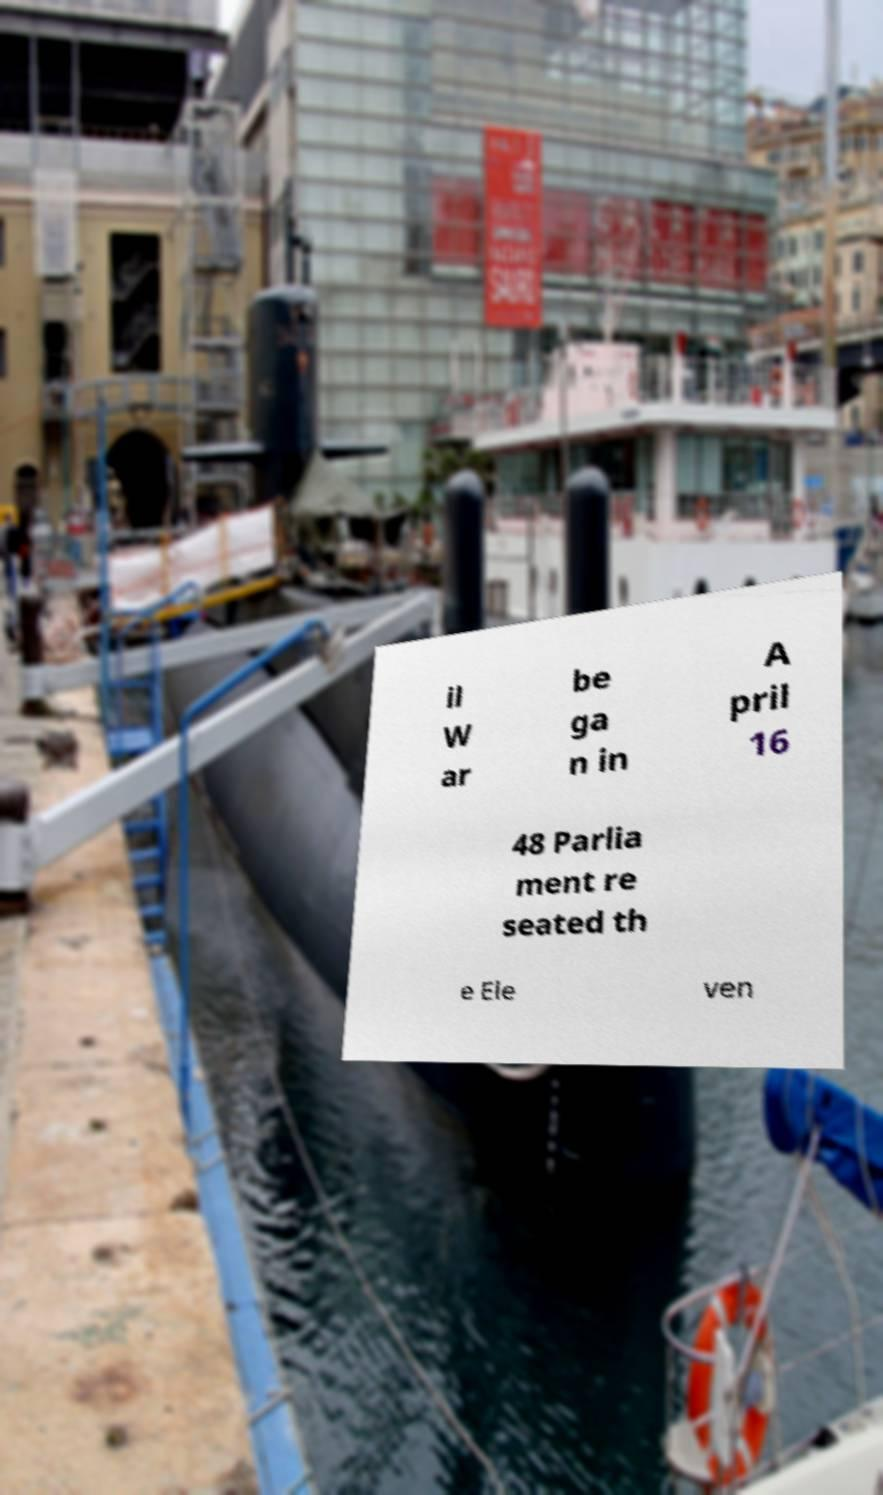What messages or text are displayed in this image? I need them in a readable, typed format. il W ar be ga n in A pril 16 48 Parlia ment re seated th e Ele ven 